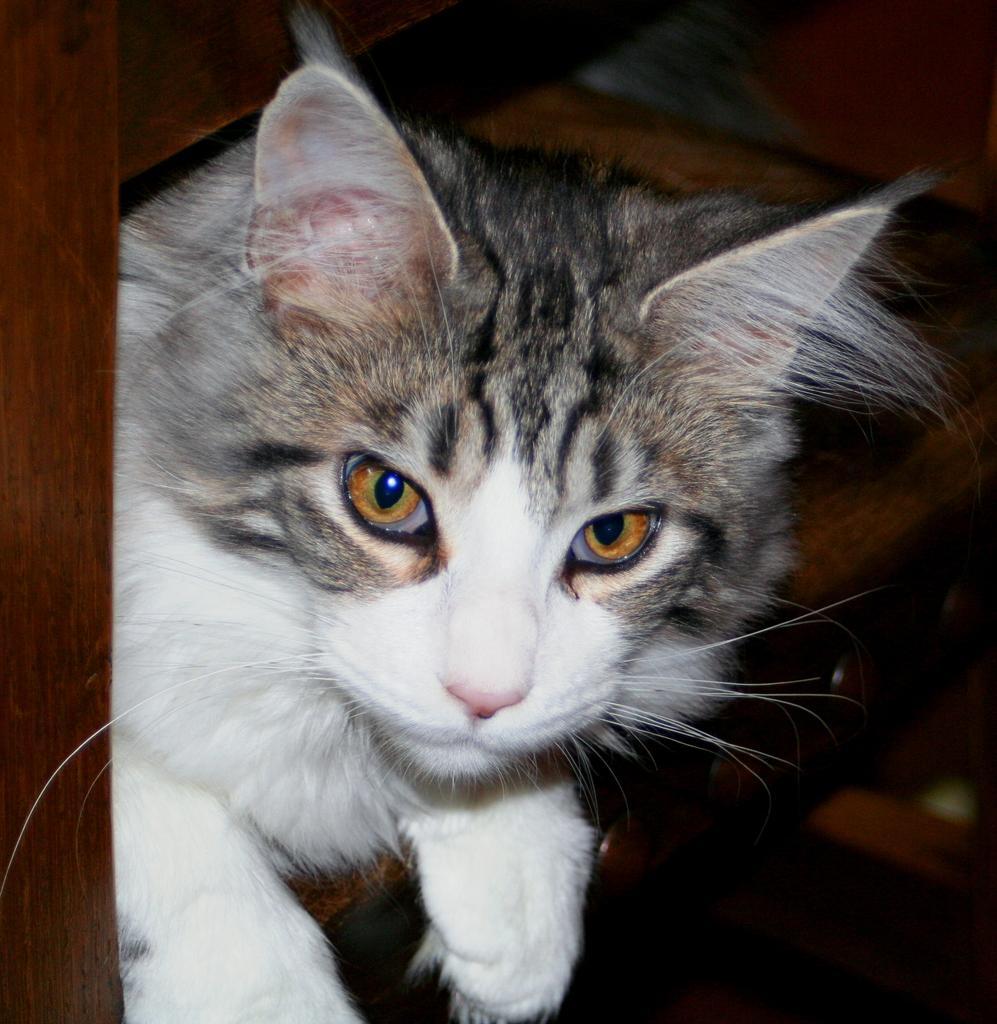In one or two sentences, can you explain what this image depicts? In this picture we can see a cat and wooden object. 